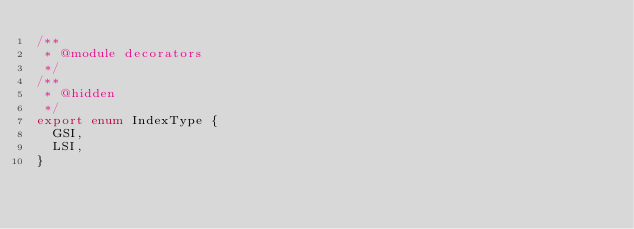<code> <loc_0><loc_0><loc_500><loc_500><_TypeScript_>/**
 * @module decorators
 */
/**
 * @hidden
 */
export enum IndexType {
  GSI,
  LSI,
}
</code> 